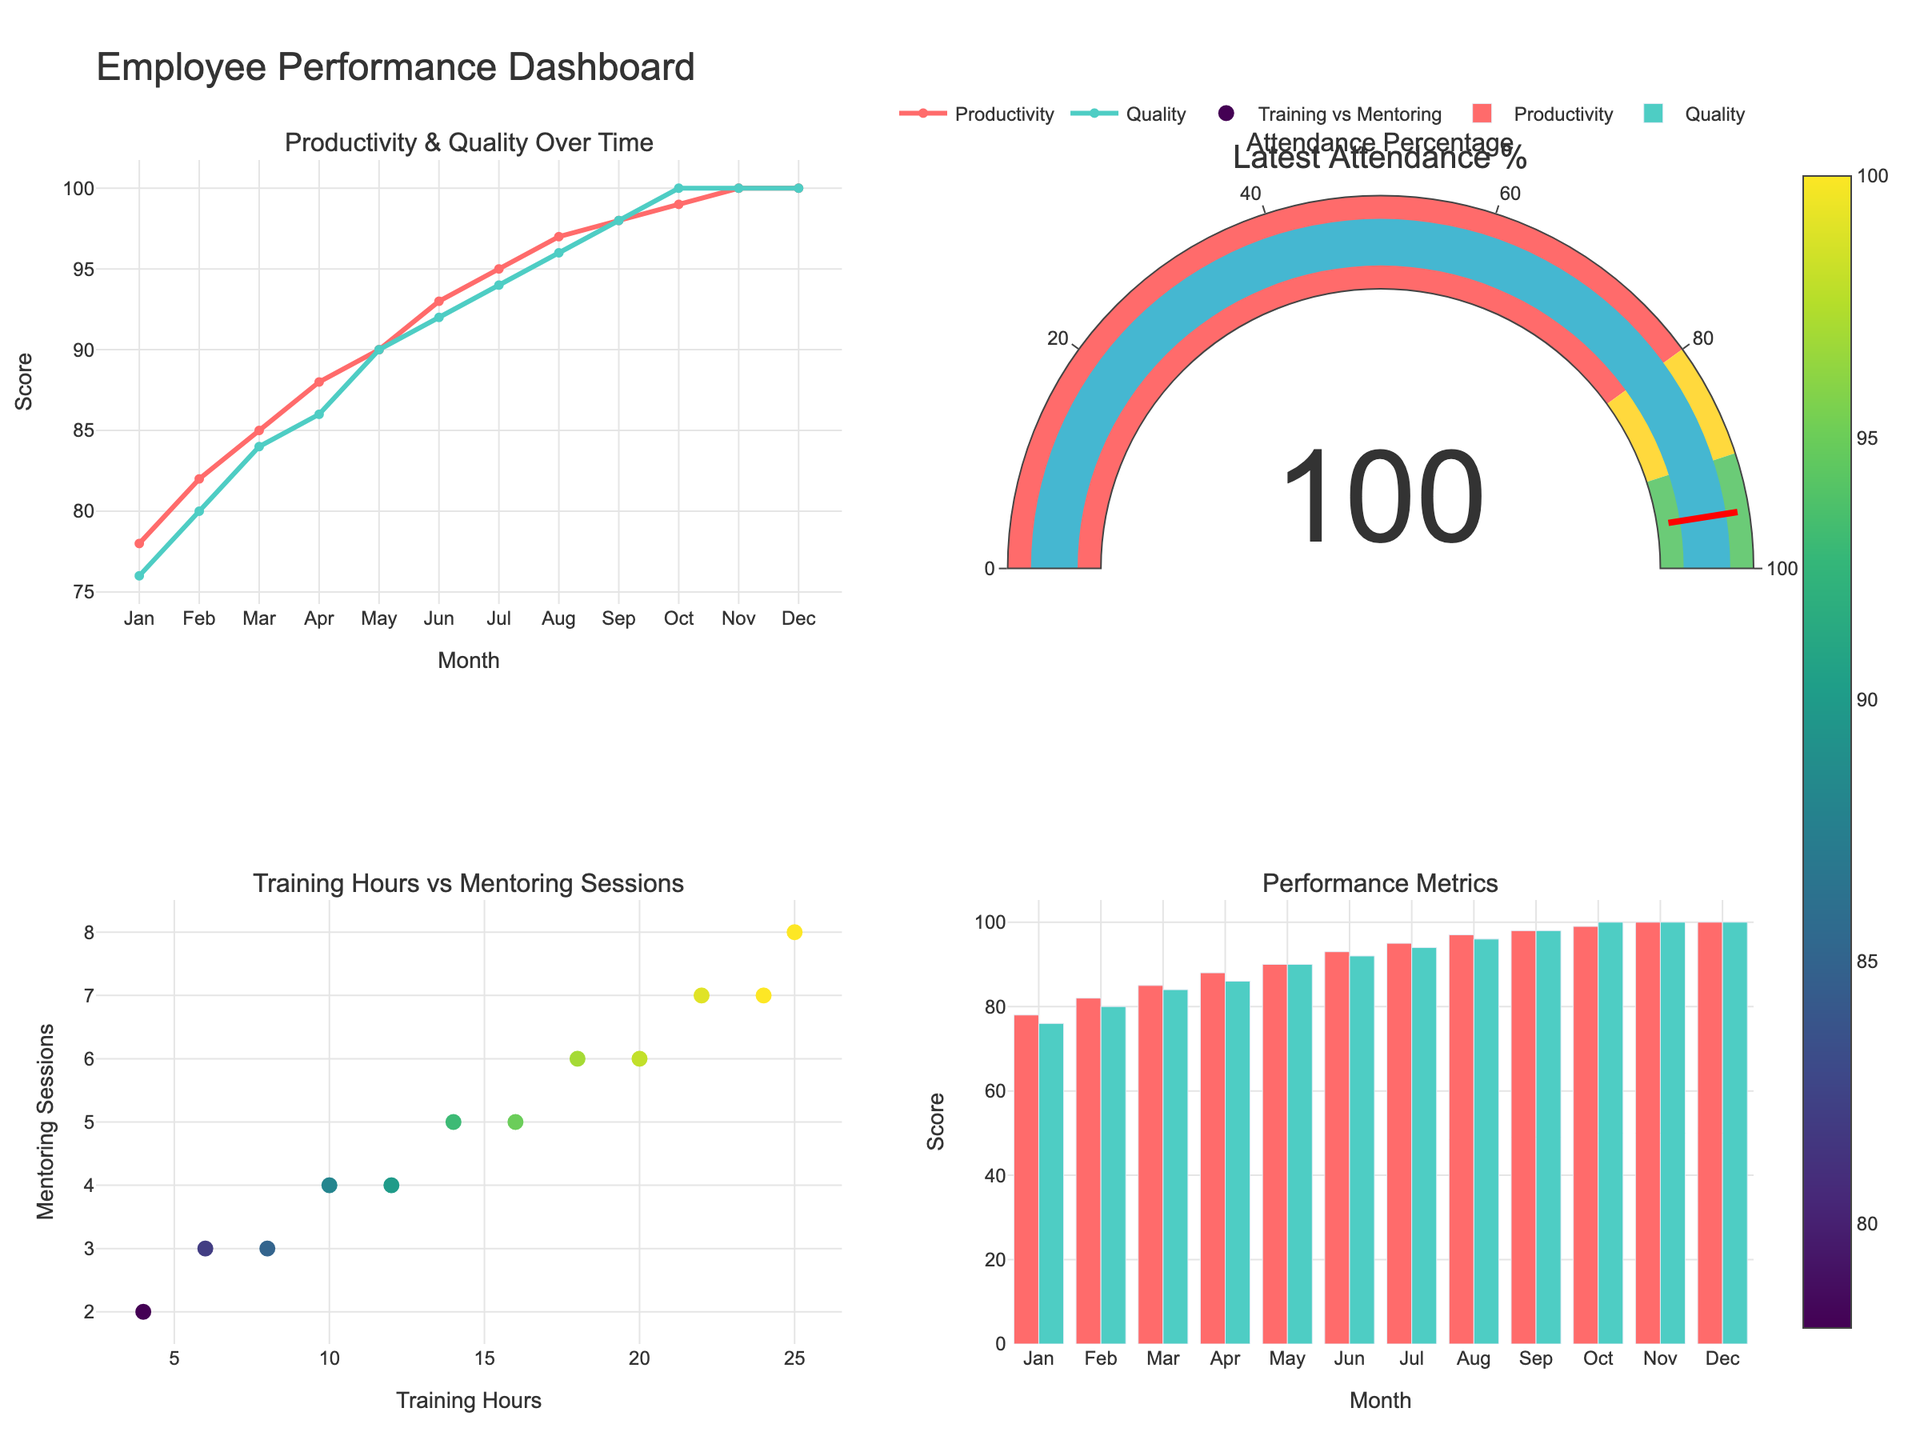What's the title of this dashboard? The title of the dashboard is located at the top center of the plot. It reads "Employee Performance Dashboard".
Answer: Employee Performance Dashboard What is the latest attendance percentage? The gauge chart on the top right subplot shows the latest attendance percentage. The number in the center of the gauge reads "100%".
Answer: 100% How have productivity scores changed from January to December? By looking at the line plot of the Productivity Score in the top left subplot, starting from Jan to Dec, the scores have increased from 78 to 100.
Answer: Increased from 78 to 100 Which month experienced the highest number of training hours? Training Hours are shown on the bottom left subplot, where the month with the highest value on the x-axis is December with 25 hours.
Answer: December What is the relationship between training hours and mentoring sessions? The scatter plot in the bottom left subplot shows a general trend where more training hours are associated with more mentoring sessions, indicating a positive relationship.
Answer: Positive relationship How does Quality Rating compare to Productivity Score over time? In the top left subplot, the Quality Rating (scaled to align with the Productivity Score) consistently increases along with the Productivity Score, indicating a correlating upward trend.
Answer: Both increase over time Compare the productivity scores and quality ratings in May. According to the bar chart in the bottom right subplot for May, the productivity score is 90 and the quality rating (scaled by 20) is 90. Both metrics have the same value in May.
Answer: Both are 90 Which metric showed no change in value for the last three months? In the line plot and bar chart on the bottom right subplot, the Quality Rating flattened out at 5.0 (scaled at 100) for the last three months.
Answer: Quality Rating Are there any months where attendance percentage dropped below 98%? The line plot in the bottom left subplot shows the Attendance Percentage over months. Attendance dropped below 98% in January and April, where they were 95% and 96% respectively.
Answer: January and April Is the productivity trend linear or non-linear? By examining the highest line plot for the Productivity Score in the top left subplot, the increments in productivity from month to month suggest a non-linear trend. The increases become larger towards the end of the year.
Answer: Non-linear 